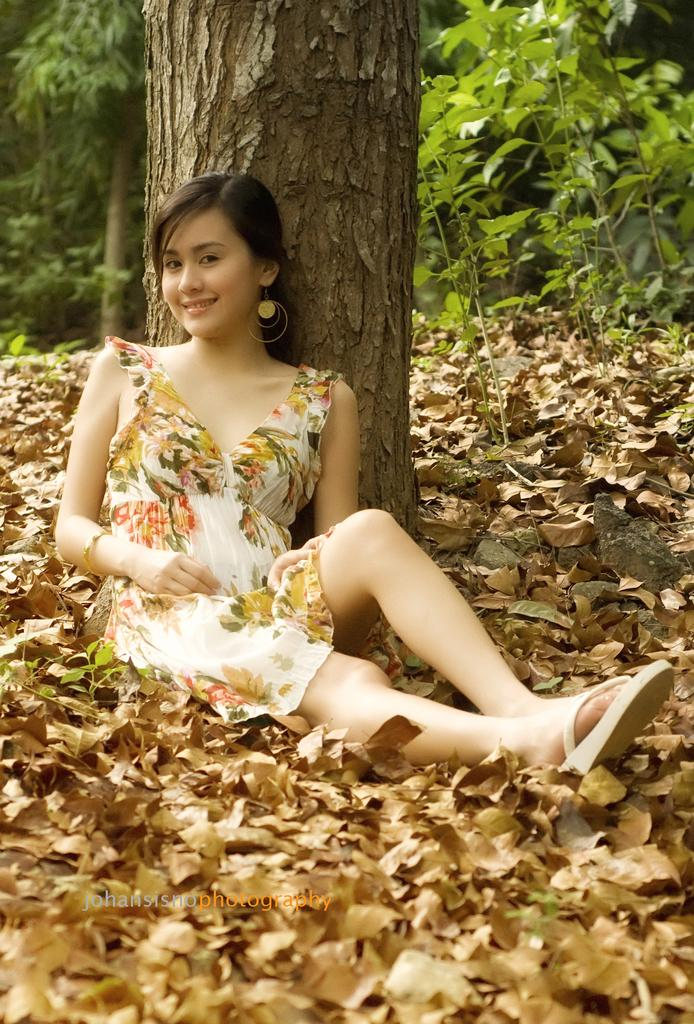What is the lady doing in the image? The lady is sitting near a tree trunk in the image. What can be seen on the ground around the lady? Dried leaves are present on the ground. What is visible in the background of the image? There are trees in the background. Can you describe any additional features of the image? There is a watermark on the image. What type of help can be seen being offered to the lady in the image? There is no indication of anyone offering help to the lady in the image. Can you describe the clouds in the image? There are no clouds visible in the image; it only shows a lady sitting near a tree trunk, dried leaves on the ground, trees in the background, and a watermark. 